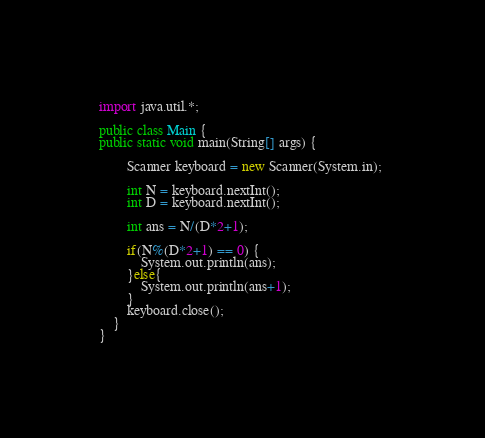Convert code to text. <code><loc_0><loc_0><loc_500><loc_500><_Java_>import java.util.*;

public class Main {
public static void main(String[] args) {
		
		Scanner keyboard = new Scanner(System.in); 
		
		int N = keyboard.nextInt();
		int D = keyboard.nextInt();
		
		int ans = N/(D*2+1);
		
		if(N%(D*2+1) == 0) { 
			System.out.println(ans);
		}else{
			System.out.println(ans+1);
		}
		keyboard.close();	
	}
}
</code> 